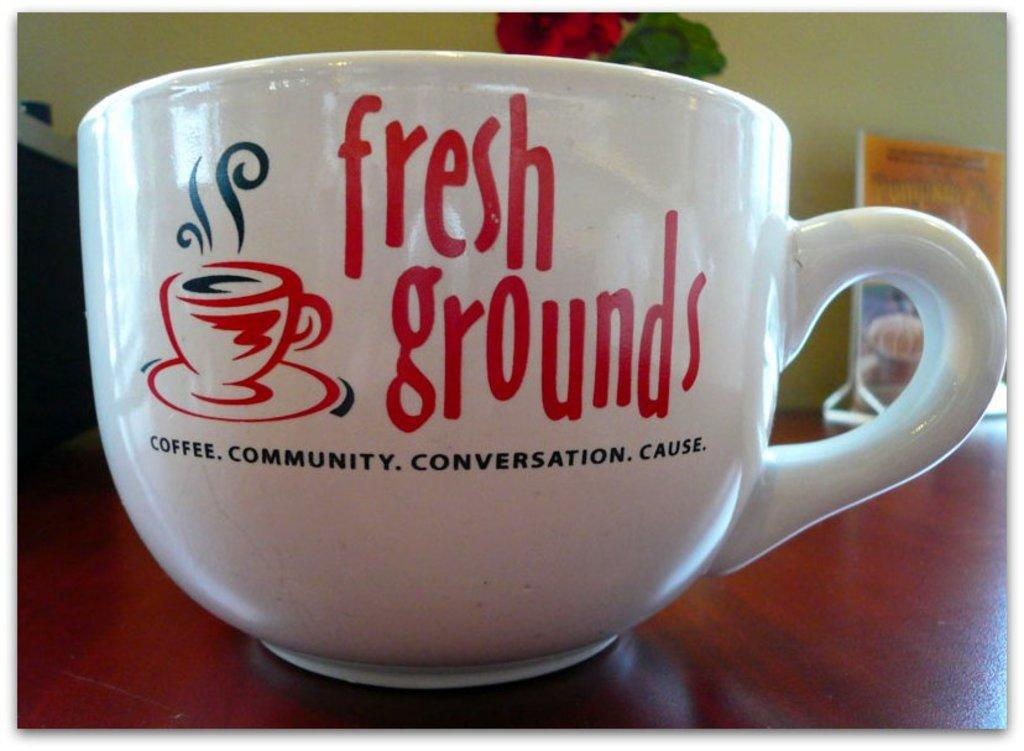<image>
Relay a brief, clear account of the picture shown. A large cappucino mug that says fresh grounds. 